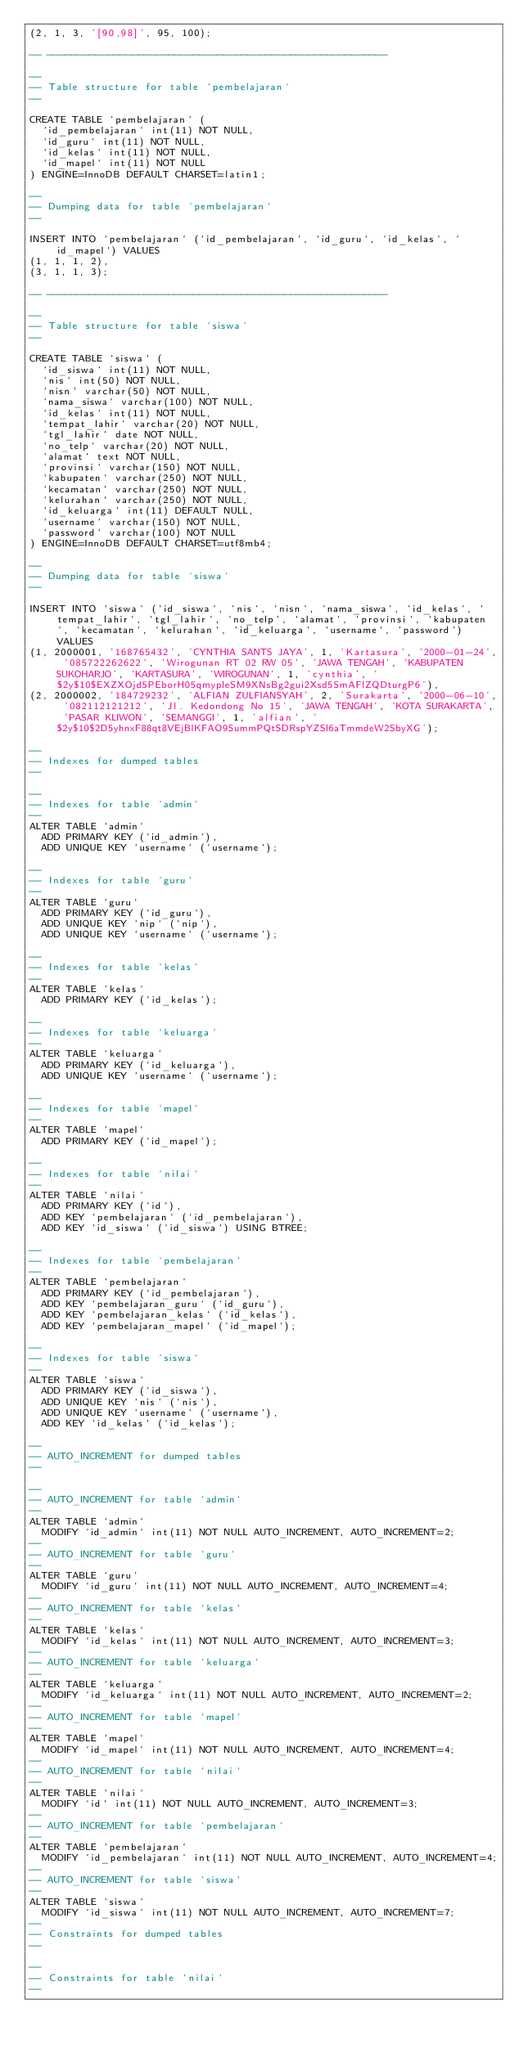<code> <loc_0><loc_0><loc_500><loc_500><_SQL_>(2, 1, 3, '[90,98]', 95, 100);

-- --------------------------------------------------------

--
-- Table structure for table `pembelajaran`
--

CREATE TABLE `pembelajaran` (
  `id_pembelajaran` int(11) NOT NULL,
  `id_guru` int(11) NOT NULL,
  `id_kelas` int(11) NOT NULL,
  `id_mapel` int(11) NOT NULL
) ENGINE=InnoDB DEFAULT CHARSET=latin1;

--
-- Dumping data for table `pembelajaran`
--

INSERT INTO `pembelajaran` (`id_pembelajaran`, `id_guru`, `id_kelas`, `id_mapel`) VALUES
(1, 1, 1, 2),
(3, 1, 1, 3);

-- --------------------------------------------------------

--
-- Table structure for table `siswa`
--

CREATE TABLE `siswa` (
  `id_siswa` int(11) NOT NULL,
  `nis` int(50) NOT NULL,
  `nisn` varchar(50) NOT NULL,
  `nama_siswa` varchar(100) NOT NULL,
  `id_kelas` int(11) NOT NULL,
  `tempat_lahir` varchar(20) NOT NULL,
  `tgl_lahir` date NOT NULL,
  `no_telp` varchar(20) NOT NULL,
  `alamat` text NOT NULL,
  `provinsi` varchar(150) NOT NULL,
  `kabupaten` varchar(250) NOT NULL,
  `kecamatan` varchar(250) NOT NULL,
  `kelurahan` varchar(250) NOT NULL,
  `id_keluarga` int(11) DEFAULT NULL,
  `username` varchar(150) NOT NULL,
  `password` varchar(100) NOT NULL
) ENGINE=InnoDB DEFAULT CHARSET=utf8mb4;

--
-- Dumping data for table `siswa`
--

INSERT INTO `siswa` (`id_siswa`, `nis`, `nisn`, `nama_siswa`, `id_kelas`, `tempat_lahir`, `tgl_lahir`, `no_telp`, `alamat`, `provinsi`, `kabupaten`, `kecamatan`, `kelurahan`, `id_keluarga`, `username`, `password`) VALUES
(1, 2000001, '168765432', 'CYNTHIA SANTS JAYA', 1, 'Kartasura', '2000-01-24', '085722262622', 'Wirogunan RT 02 RW 05', 'JAWA TENGAH', 'KABUPATEN SUKOHARJO', 'KARTASURA', 'WIROGUNAN', 1, 'cynthia', '$2y$10$EXZXOjd5PEborH05qmypleSM9XNsBg2gui2Xsd5SmAFlZQDturgP6'),
(2, 2000002, '184729232', 'ALFIAN ZULFIANSYAH', 2, 'Surakarta', '2000-06-10', '082112121212', 'Jl. Kedondong No 15', 'JAWA TENGAH', 'KOTA SURAKARTA', 'PASAR KLIWON', 'SEMANGGI', 1, 'alfian', '$2y$10$2D5yhnxF88qt8VEjBlKFAO9SummPQtSDRspYZSl6aTmmdeW2SbyXG');

--
-- Indexes for dumped tables
--

--
-- Indexes for table `admin`
--
ALTER TABLE `admin`
  ADD PRIMARY KEY (`id_admin`),
  ADD UNIQUE KEY `username` (`username`);

--
-- Indexes for table `guru`
--
ALTER TABLE `guru`
  ADD PRIMARY KEY (`id_guru`),
  ADD UNIQUE KEY `nip` (`nip`),
  ADD UNIQUE KEY `username` (`username`);

--
-- Indexes for table `kelas`
--
ALTER TABLE `kelas`
  ADD PRIMARY KEY (`id_kelas`);

--
-- Indexes for table `keluarga`
--
ALTER TABLE `keluarga`
  ADD PRIMARY KEY (`id_keluarga`),
  ADD UNIQUE KEY `username` (`username`);

--
-- Indexes for table `mapel`
--
ALTER TABLE `mapel`
  ADD PRIMARY KEY (`id_mapel`);

--
-- Indexes for table `nilai`
--
ALTER TABLE `nilai`
  ADD PRIMARY KEY (`id`),
  ADD KEY `pembelajaran` (`id_pembelajaran`),
  ADD KEY `id_siswa` (`id_siswa`) USING BTREE;

--
-- Indexes for table `pembelajaran`
--
ALTER TABLE `pembelajaran`
  ADD PRIMARY KEY (`id_pembelajaran`),
  ADD KEY `pembelajaran_guru` (`id_guru`),
  ADD KEY `pembelajaran_kelas` (`id_kelas`),
  ADD KEY `pembelajaran_mapel` (`id_mapel`);

--
-- Indexes for table `siswa`
--
ALTER TABLE `siswa`
  ADD PRIMARY KEY (`id_siswa`),
  ADD UNIQUE KEY `nis` (`nis`),
  ADD UNIQUE KEY `username` (`username`),
  ADD KEY `id_kelas` (`id_kelas`);

--
-- AUTO_INCREMENT for dumped tables
--

--
-- AUTO_INCREMENT for table `admin`
--
ALTER TABLE `admin`
  MODIFY `id_admin` int(11) NOT NULL AUTO_INCREMENT, AUTO_INCREMENT=2;
--
-- AUTO_INCREMENT for table `guru`
--
ALTER TABLE `guru`
  MODIFY `id_guru` int(11) NOT NULL AUTO_INCREMENT, AUTO_INCREMENT=4;
--
-- AUTO_INCREMENT for table `kelas`
--
ALTER TABLE `kelas`
  MODIFY `id_kelas` int(11) NOT NULL AUTO_INCREMENT, AUTO_INCREMENT=3;
--
-- AUTO_INCREMENT for table `keluarga`
--
ALTER TABLE `keluarga`
  MODIFY `id_keluarga` int(11) NOT NULL AUTO_INCREMENT, AUTO_INCREMENT=2;
--
-- AUTO_INCREMENT for table `mapel`
--
ALTER TABLE `mapel`
  MODIFY `id_mapel` int(11) NOT NULL AUTO_INCREMENT, AUTO_INCREMENT=4;
--
-- AUTO_INCREMENT for table `nilai`
--
ALTER TABLE `nilai`
  MODIFY `id` int(11) NOT NULL AUTO_INCREMENT, AUTO_INCREMENT=3;
--
-- AUTO_INCREMENT for table `pembelajaran`
--
ALTER TABLE `pembelajaran`
  MODIFY `id_pembelajaran` int(11) NOT NULL AUTO_INCREMENT, AUTO_INCREMENT=4;
--
-- AUTO_INCREMENT for table `siswa`
--
ALTER TABLE `siswa`
  MODIFY `id_siswa` int(11) NOT NULL AUTO_INCREMENT, AUTO_INCREMENT=7;
--
-- Constraints for dumped tables
--

--
-- Constraints for table `nilai`
--</code> 